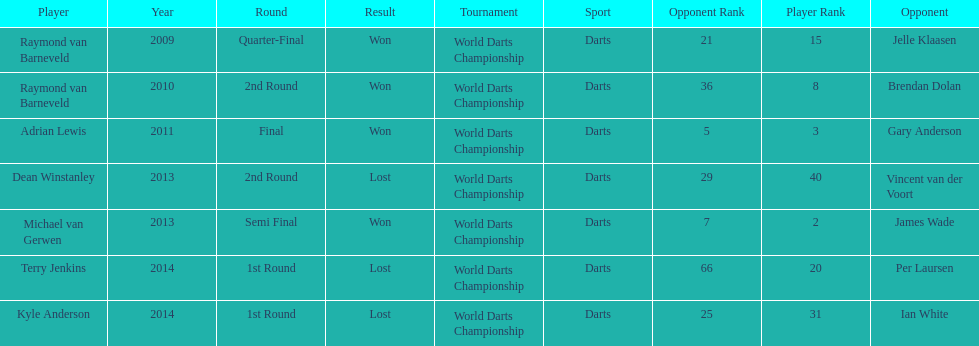Excluding kyle anderson, who else faced a setback in 2014? Terry Jenkins. 